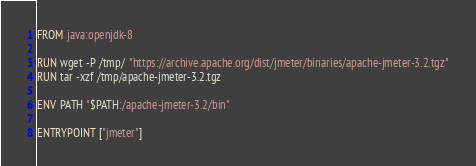Convert code to text. <code><loc_0><loc_0><loc_500><loc_500><_Dockerfile_>FROM java:openjdk-8

RUN wget -P /tmp/ "https://archive.apache.org/dist/jmeter/binaries/apache-jmeter-3.2.tgz"
RUN tar -xzf /tmp/apache-jmeter-3.2.tgz

ENV PATH "$PATH:/apache-jmeter-3.2/bin"

ENTRYPOINT ["jmeter"]
</code> 